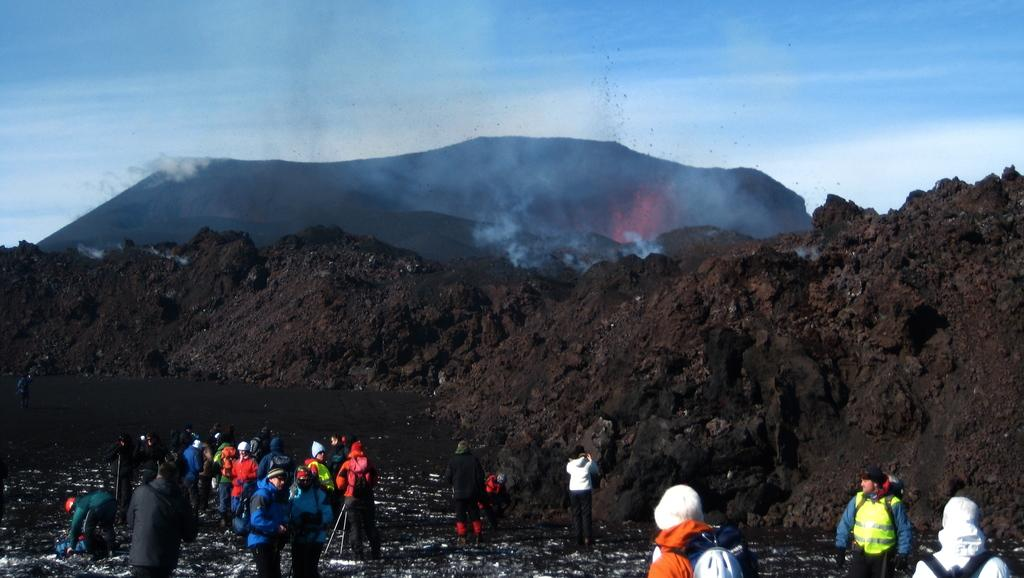How many people are in the image? There is a group of people in the image, but the exact number is not specified. What can be seen in the background of the image? Soil, mountains, and the sky are visible in the background of the image. What type of natural feature is present in the background of the image? Mountains are present in the background of the image. What part of the natural environment is visible in the image? The sky is visible in the background of the image. What type of patch is being sewn by the girls in the image? There are no girls or patches present in the image. 